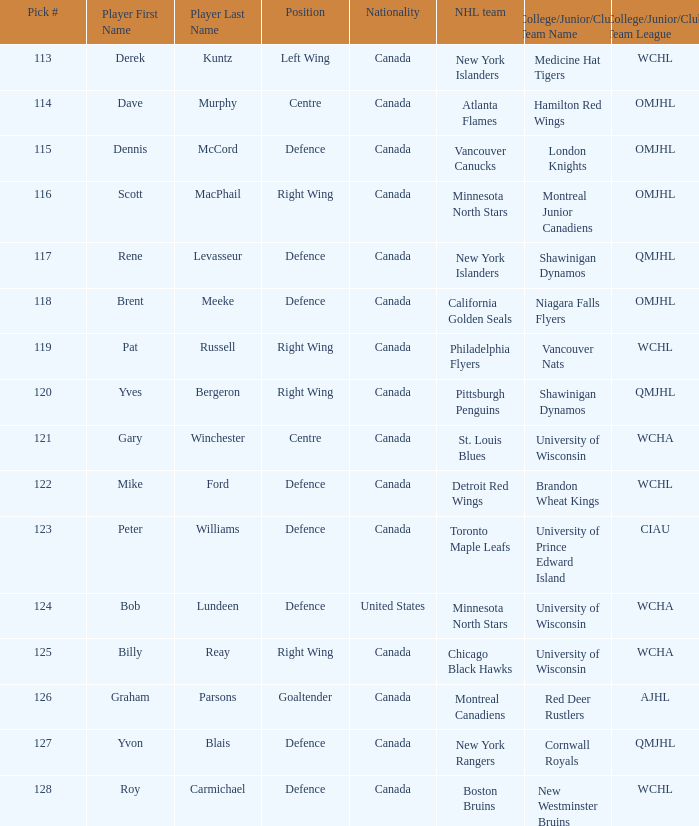Name the player for chicago black hawks Billy Reay. 